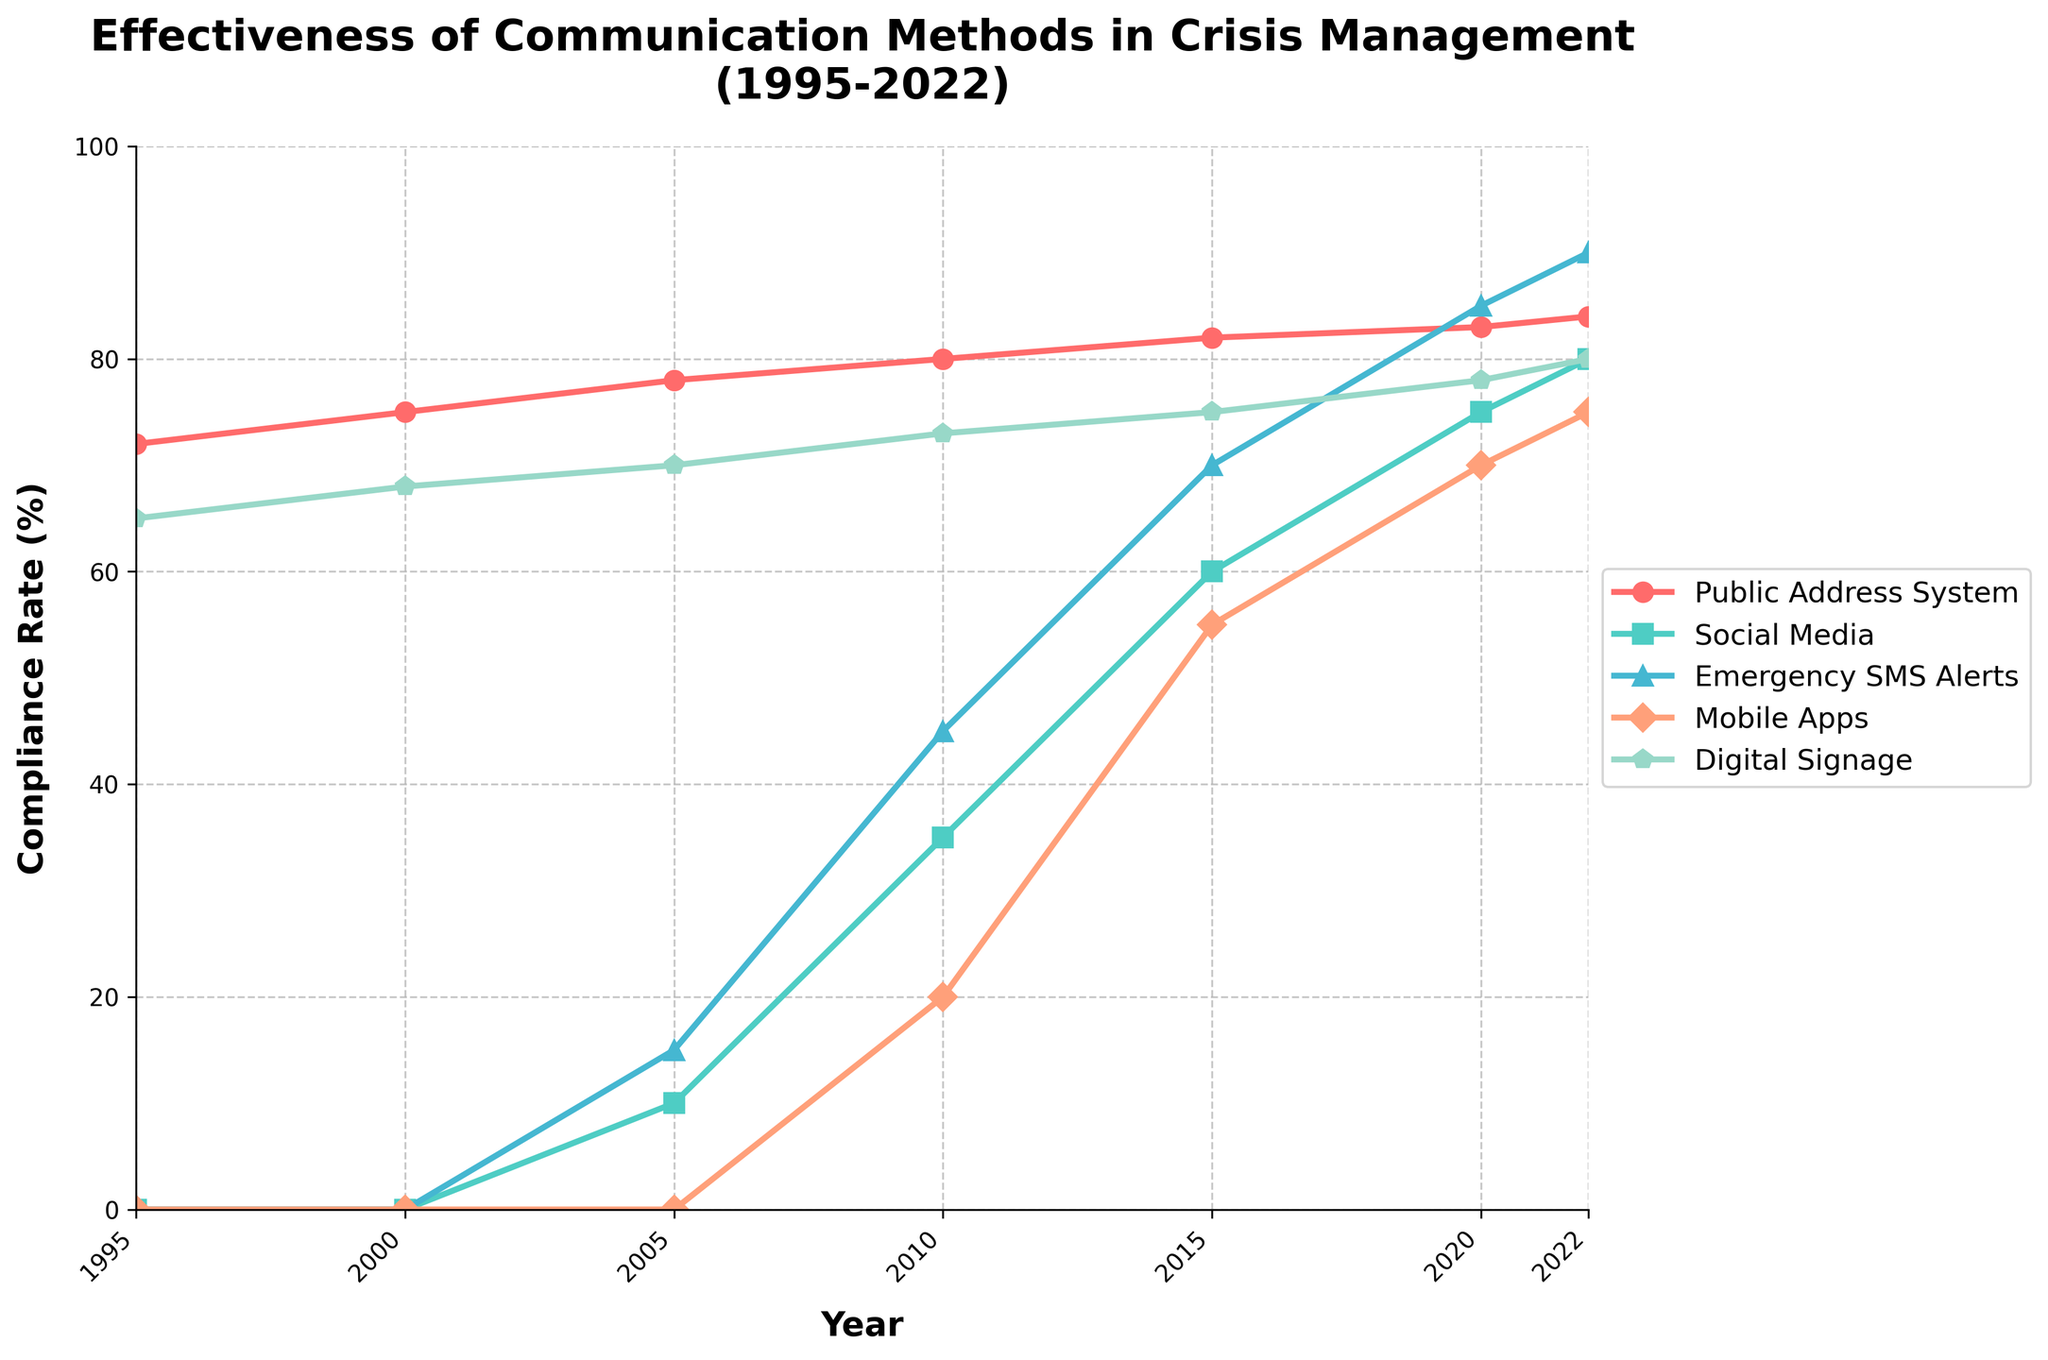Which communication method had the highest compliance rate in 2022? Look at the 2022 data points for each communication method and identify the method with the highest compliance rate.
Answer: Emergency SMS Alerts How did the compliance rate for Social Media change from 2005 to 2022? Subtract the compliance rate for Social Media in 2005 from the compliance rate in 2022 (80 - 10).
Answer: Increased by 70 Which communication method showed the most consistent increase in compliance rate from 1995 to 2022? Examine the slopes of the lines over the entire period. The Public Address System shows a consistent, steady increase without any drops.
Answer: Public Address System What is the difference in compliance rate between Emergency SMS Alerts and Digital Signage in 2020? Find the compliance rates for both Emergency SMS Alerts and Digital Signage in 2020 then subtract the rate of Digital Signage from that of Emergency SMS Alerts (85 - 78).
Answer: 7 Compare the compliance rates of Mobile Apps between 2010 and 2022. By how much did it increase? Look at the compliance rates for Mobile Apps in 2010 and 2022 and subtract the 2010 rate from the 2022 rate (75 - 20).
Answer: Increased by 55 Which communication method first appeared in the dataset in 2010 and what was its initial compliance rate? Observe the year each communication method first has a non-zero compliance rate. Mobile Apps first appear in 2010 with a compliance rate of 20.
Answer: Mobile Apps, 20 Between which two consecutive years did Digital Signage experience the largest increase in compliance rate? Calculate the differences in compliance rate for Digital Signage between each pair of consecutive years and identify the largest one (2010 to 2015: 75 - 73 = 2, the largest difference).
Answer: 2010 to 2015 What is the sum of the compliance rates of Social Media and Emergency SMS Alerts in 2022? Add the compliance rates of Social Media and Emergency SMS Alerts in 2022 (80 + 90).
Answer: 170 Does any communication method show a decrease in compliance rate at any point between 1995 and 2022? Review the lines for all methods and check for any downward trends. No method exhibits a decrease over the given time period.
Answer: No What was the compliance rate for the Public Address System in 2015 and how does it compare to Digital Signage in the same year? Note the compliance rates of both the Public Address System and Digital Signage in 2015 (both 82 and 75 respectively), then compare them.
Answer: Public Address System: 82, Digital Signage: 75. Public Address System had a higher rate 